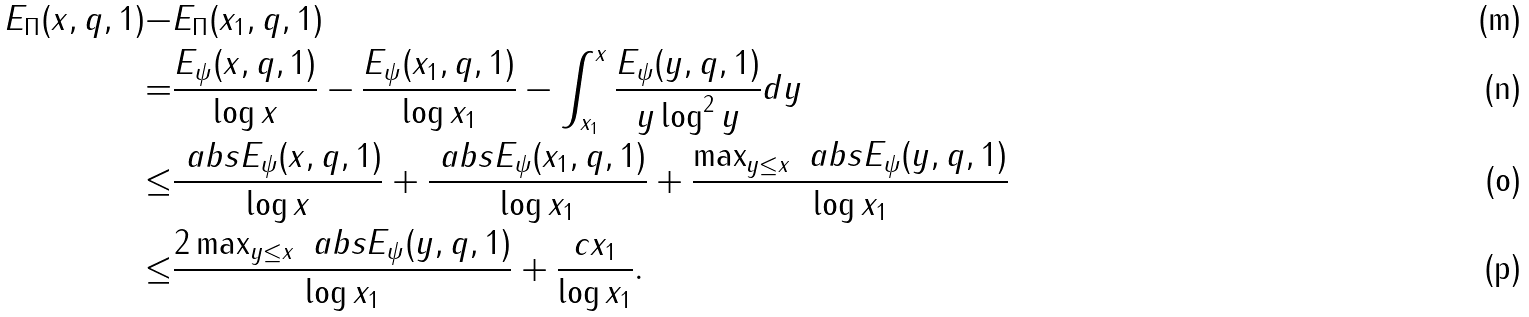Convert formula to latex. <formula><loc_0><loc_0><loc_500><loc_500>E _ { \Pi } ( x , q , 1 ) - & E _ { \Pi } ( x _ { 1 } , q , 1 ) \\ = & \frac { E _ { \psi } ( x , q , 1 ) } { \log x } - \frac { E _ { \psi } ( x _ { 1 } , q , 1 ) } { \log x _ { 1 } } - \int _ { x _ { 1 } } ^ { x } \frac { E _ { \psi } ( y , q , 1 ) } { y \log ^ { 2 } y } d y \\ \leq & \frac { \ a b s { E _ { \psi } ( x , q , 1 ) } } { \log x } + \frac { \ a b s { E _ { \psi } ( x _ { 1 } , q , 1 ) } } { \log x _ { 1 } } + \frac { \max _ { y \leq x } \ a b s { E _ { \psi } ( y , q , 1 ) } } { \log x _ { 1 } } \\ \leq & \frac { 2 \max _ { y \leq x } \ a b s { E _ { \psi } ( y , q , 1 ) } } { \log x _ { 1 } } + \frac { c x _ { 1 } } { \log x _ { 1 } } .</formula> 